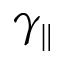Convert formula to latex. <formula><loc_0><loc_0><loc_500><loc_500>\gamma _ { \| }</formula> 